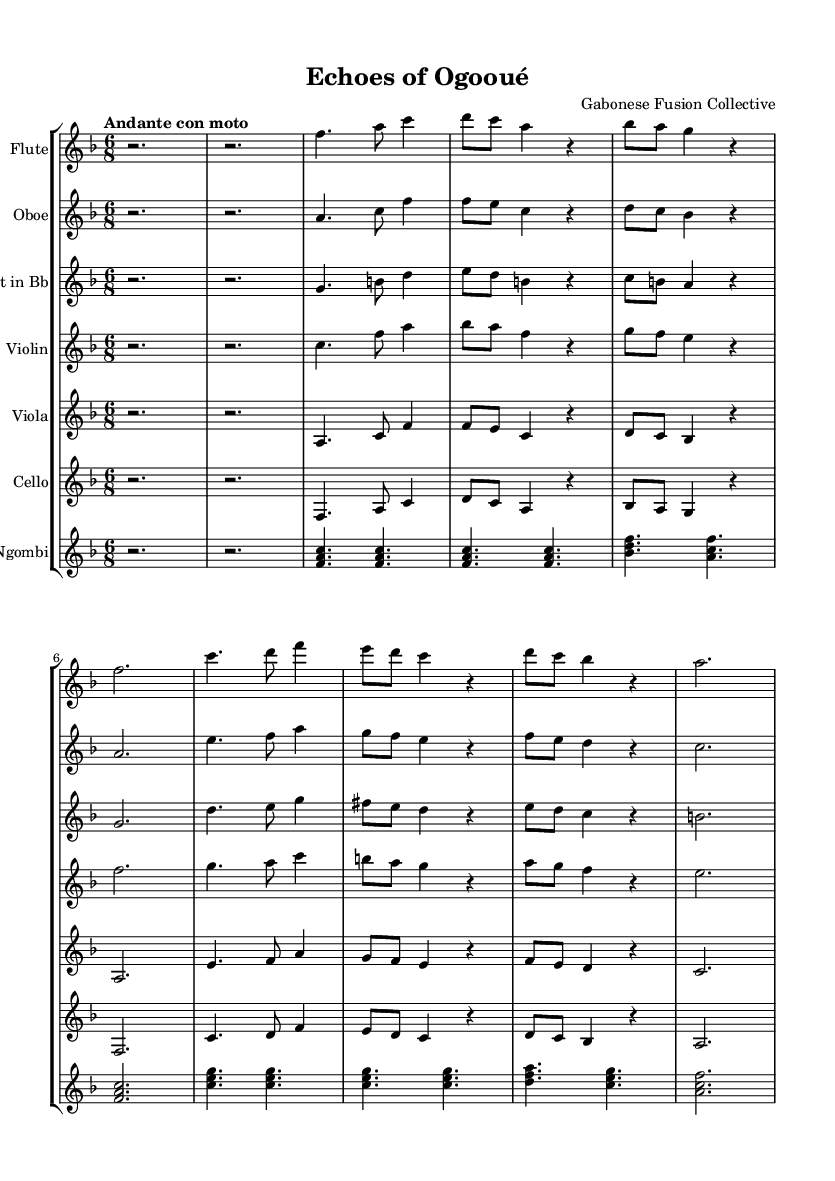What is the key signature of this music? The key signature is F major, which has one flat (B flat).
Answer: F major What is the time signature of this piece? The time signature is 6/8, indicating a compound meter with six eighth notes per measure.
Answer: 6/8 What is the tempo marking for this composition? The tempo marking is "Andante con moto," suggesting a moderate, flowing pace.
Answer: Andante con moto How many themes are present in the piece? The piece consists of two themes, labeled Theme A and Theme B.
Answer: Two themes What instruments are featured in this score? The score features flute, oboe, clarinet, violin, viola, cello, and ngombi.
Answer: Flute, oboe, clarinet, violin, viola, cello, ngombi Which instrument plays the introduction to the piece? The introduction is played by all instruments, as indicated by the repeated rest measures at the beginning.
Answer: All instruments What is the main rhythmic pattern used in Theme A? Theme A employs a combination of quarter and eighth notes, creating a flowing rhythmic pattern unique to the theme.
Answer: Quarter and eighth notes 